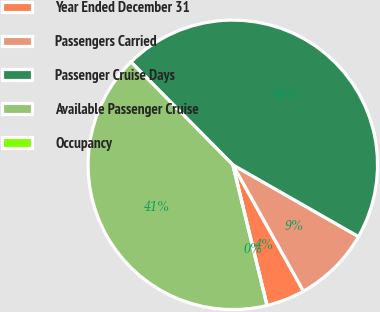Convert chart. <chart><loc_0><loc_0><loc_500><loc_500><pie_chart><fcel>Year Ended December 31<fcel>Passengers Carried<fcel>Passenger Cruise Days<fcel>Available Passenger Cruise<fcel>Occupancy<nl><fcel>4.32%<fcel>8.63%<fcel>45.68%<fcel>41.37%<fcel>0.0%<nl></chart> 